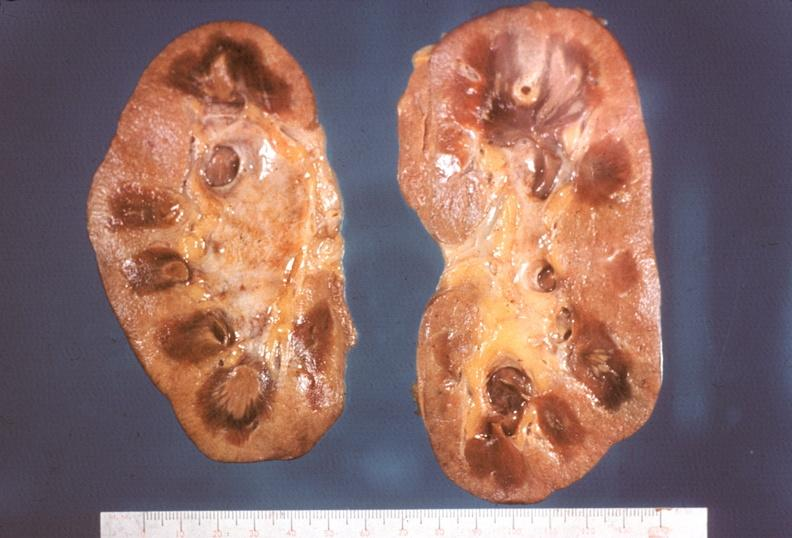what necrotizing?
Answer the question using a single word or phrase. Kidney 